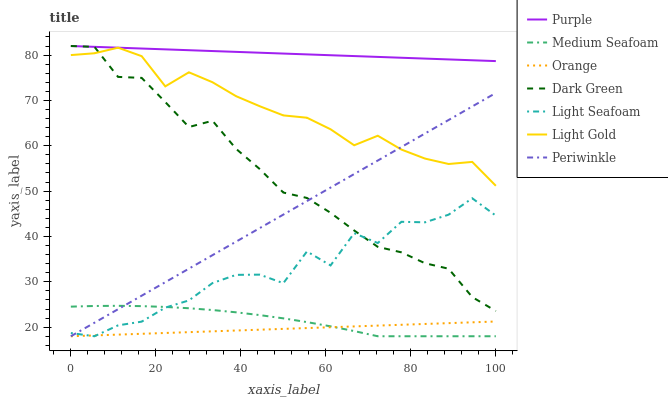Does Orange have the minimum area under the curve?
Answer yes or no. Yes. Does Purple have the maximum area under the curve?
Answer yes or no. Yes. Does Periwinkle have the minimum area under the curve?
Answer yes or no. No. Does Periwinkle have the maximum area under the curve?
Answer yes or no. No. Is Periwinkle the smoothest?
Answer yes or no. Yes. Is Light Seafoam the roughest?
Answer yes or no. Yes. Is Orange the smoothest?
Answer yes or no. No. Is Orange the roughest?
Answer yes or no. No. Does Light Gold have the lowest value?
Answer yes or no. No. Does Dark Green have the highest value?
Answer yes or no. Yes. Does Periwinkle have the highest value?
Answer yes or no. No. Is Light Seafoam less than Light Gold?
Answer yes or no. Yes. Is Purple greater than Light Seafoam?
Answer yes or no. Yes. Does Periwinkle intersect Orange?
Answer yes or no. Yes. Is Periwinkle less than Orange?
Answer yes or no. No. Is Periwinkle greater than Orange?
Answer yes or no. No. Does Light Seafoam intersect Light Gold?
Answer yes or no. No. 